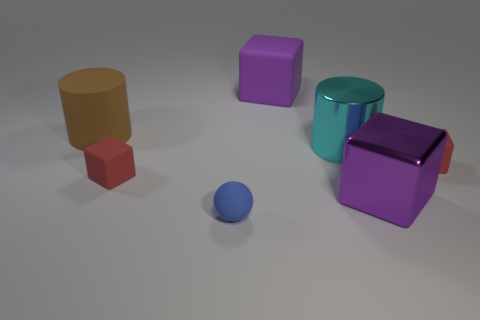Do the blue sphere and the large purple object in front of the large brown rubber thing have the same material?
Offer a terse response. No. There is a red matte block that is on the left side of the metallic cube; is its size the same as the purple matte block that is behind the big metallic cylinder?
Offer a terse response. No. There is a thing that is the same color as the large metal cube; what is it made of?
Your answer should be compact. Rubber. How many big matte blocks are the same color as the big metal block?
Your response must be concise. 1. Is the size of the blue ball the same as the cylinder that is on the left side of the blue object?
Your answer should be compact. No. There is a red rubber object that is behind the red block that is on the left side of the cylinder in front of the brown object; what size is it?
Keep it short and to the point. Small. What number of big purple matte things are in front of the big shiny block?
Offer a very short reply. 0. What material is the small thing in front of the tiny block to the left of the shiny block?
Your answer should be compact. Rubber. Is the size of the brown thing the same as the purple metallic block?
Ensure brevity in your answer.  Yes. How many objects are brown things on the left side of the sphere or large things that are left of the big purple shiny block?
Offer a terse response. 3. 